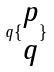Convert formula to latex. <formula><loc_0><loc_0><loc_500><loc_500>q \{ \begin{matrix} p \\ q \end{matrix} \}</formula> 